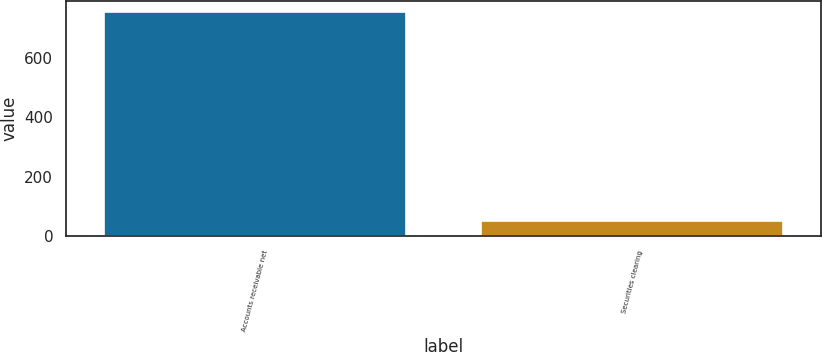Convert chart. <chart><loc_0><loc_0><loc_500><loc_500><bar_chart><fcel>Accounts receivable net<fcel>Securities clearing<nl><fcel>754<fcel>52<nl></chart> 